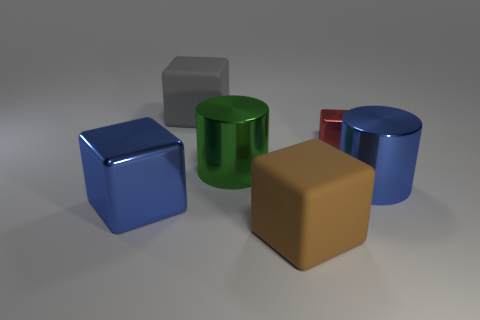What number of other things are the same material as the red thing?
Offer a terse response. 3. What number of brown things are either tiny objects or large shiny cylinders?
Ensure brevity in your answer.  0. There is a big object that is right of the brown matte cube; is its shape the same as the rubber thing that is behind the small cube?
Ensure brevity in your answer.  No. Do the small shiny cube and the object that is left of the large gray thing have the same color?
Your answer should be very brief. No. There is a metallic cylinder right of the small block; is it the same color as the large metallic cube?
Provide a short and direct response. Yes. What number of things are either tiny cubes or metallic objects that are to the left of the large green object?
Provide a succinct answer. 2. What is the cube that is both on the right side of the large gray rubber block and in front of the small metal object made of?
Offer a terse response. Rubber. There is a blue object that is to the right of the brown thing; what is it made of?
Provide a succinct answer. Metal. What color is the big block that is the same material as the tiny thing?
Ensure brevity in your answer.  Blue. Is the shape of the big green shiny thing the same as the large blue thing to the left of the small object?
Provide a short and direct response. No. 